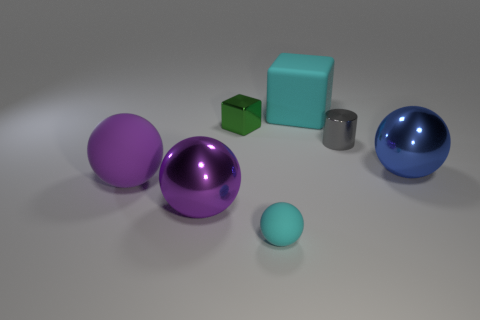What number of other things are the same size as the cylinder?
Your answer should be compact. 2. The matte object that is the same color as the tiny matte sphere is what size?
Provide a succinct answer. Large. The thing to the left of the large purple metallic thing has what shape?
Provide a succinct answer. Sphere. What color is the rubber sphere that is the same size as the gray thing?
Ensure brevity in your answer.  Cyan. Is the small object in front of the blue ball made of the same material as the cyan cube?
Your answer should be compact. Yes. What size is the matte thing that is in front of the tiny green object and to the right of the purple shiny object?
Offer a terse response. Small. There is a cyan matte object that is in front of the big cyan rubber block; what size is it?
Provide a short and direct response. Small. There is a tiny matte object that is the same color as the large cube; what shape is it?
Your response must be concise. Sphere. The big matte thing right of the large object that is in front of the matte object on the left side of the green metal object is what shape?
Offer a terse response. Cube. How many other objects are there of the same shape as the large purple matte object?
Give a very brief answer. 3. 